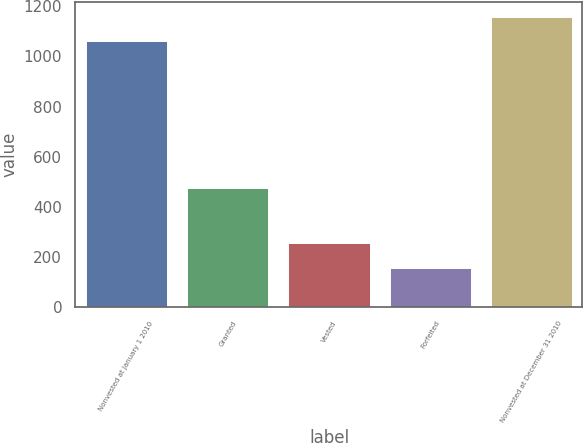<chart> <loc_0><loc_0><loc_500><loc_500><bar_chart><fcel>Nonvested at January 1 2010<fcel>Granted<fcel>Vested<fcel>Forfeited<fcel>Nonvested at December 31 2010<nl><fcel>1060<fcel>473<fcel>256.4<fcel>157<fcel>1159.4<nl></chart> 